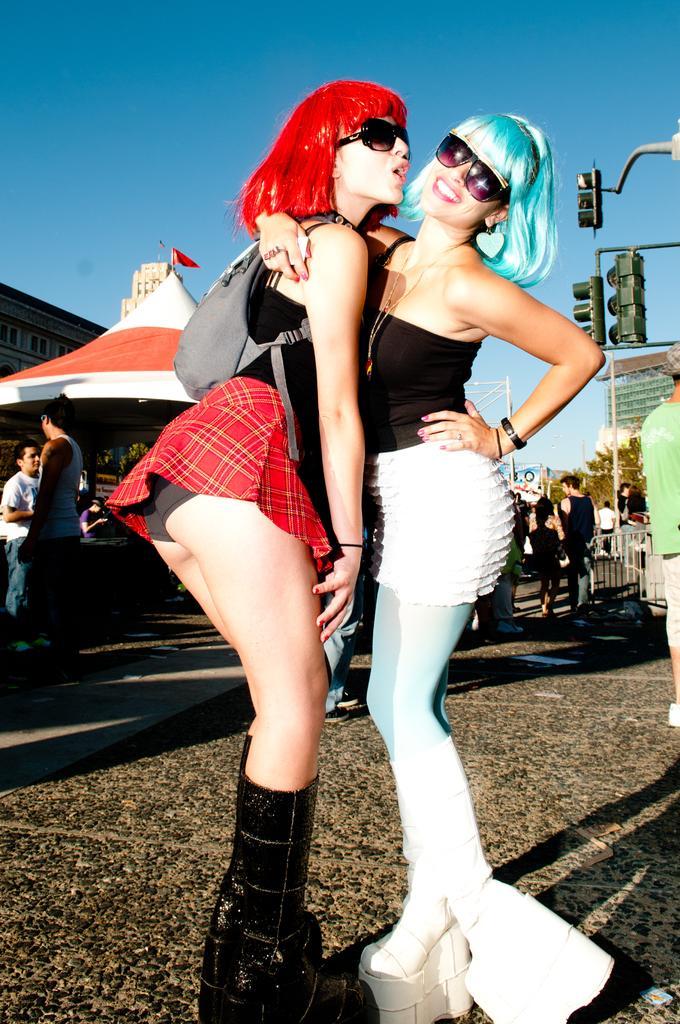Please provide a concise description of this image. This picture is clicked outside. In the center we can see the two women wearing black color t-shirts, goggles and standing on the ground. On the right we can see the traffic lights attached to the pole and we can see the group of persons. In the background there is a sky, tent, buildings and some other items. 